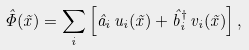<formula> <loc_0><loc_0><loc_500><loc_500>{ \hat { \Phi } } ( { \tilde { x } } ) = \sum _ { i } \left [ { \hat { a } } _ { i } \, u _ { i } ( { \tilde { x } } ) + { \hat { b } } _ { i } ^ { \dag } \, v _ { i } ( { \tilde { x } } ) \right ] ,</formula> 